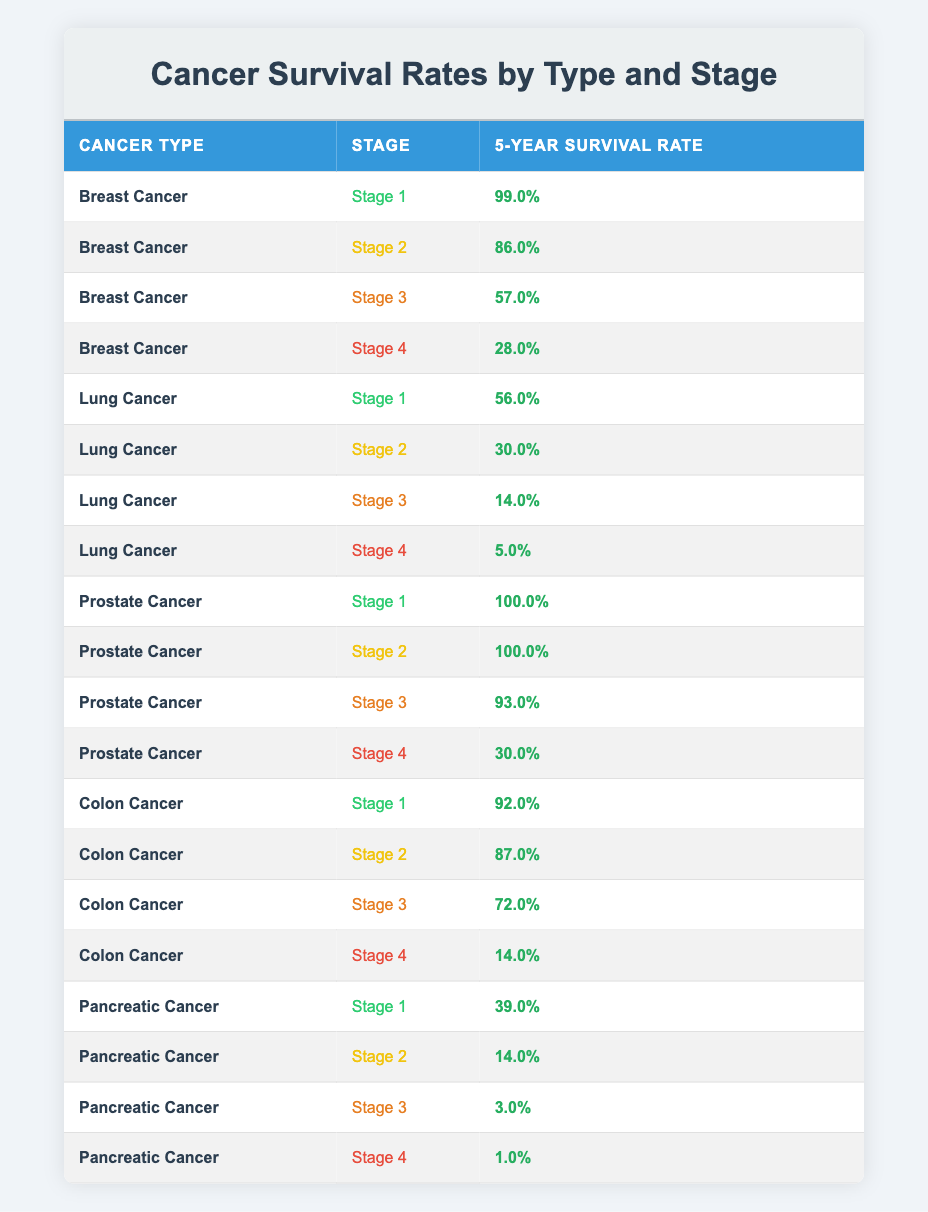What is the 5-year survival rate for Stage 4 Breast Cancer? According to the table, the 5-year survival rate for Stage 4 Breast Cancer is listed directly under that stage in the "5-Year Survival Rate" column. The rate is 28.0%.
Answer: 28.0% Which cancer type has the highest 5-year survival rate at Stage 1? Looking at the table, Prostate Cancer has a 5-year survival rate of 100.0% at Stage 1, which is higher than any other cancer type listed for the same stage.
Answer: Prostate Cancer What is the difference in 5-year survival rates between Stage 3 and Stage 4 for Colon Cancer? The 5-year survival rate for Colon Cancer at Stage 3 is 72.0% and for Stage 4 it is 14.0%. The difference can be calculated as 72.0% - 14.0% = 58.0%.
Answer: 58.0% Is the 5-year survival rate for Stage 2 Lung Cancer greater than that for Stage 3 Colon Cancer? The 5-year survival rate for Stage 2 Lung Cancer is 30.0%, while for Stage 3 Colon Cancer it is 72.0%. Since 30.0% is not greater than 72.0%, the statement is false.
Answer: No What is the average 5-year survival rate for Prostate Cancer across all stages? The 5-year survival rates for Prostate Cancer are: Stage 1 (100.0%), Stage 2 (100.0%), Stage 3 (93.0%), and Stage 4 (30.0%). To find the average, we sum these values: 100.0 + 100.0 + 93.0 + 30.0 = 323.0. Then, we divide by the number of stages (4): 323.0 / 4 = 80.75.
Answer: 80.75 